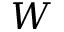<formula> <loc_0><loc_0><loc_500><loc_500>W</formula> 